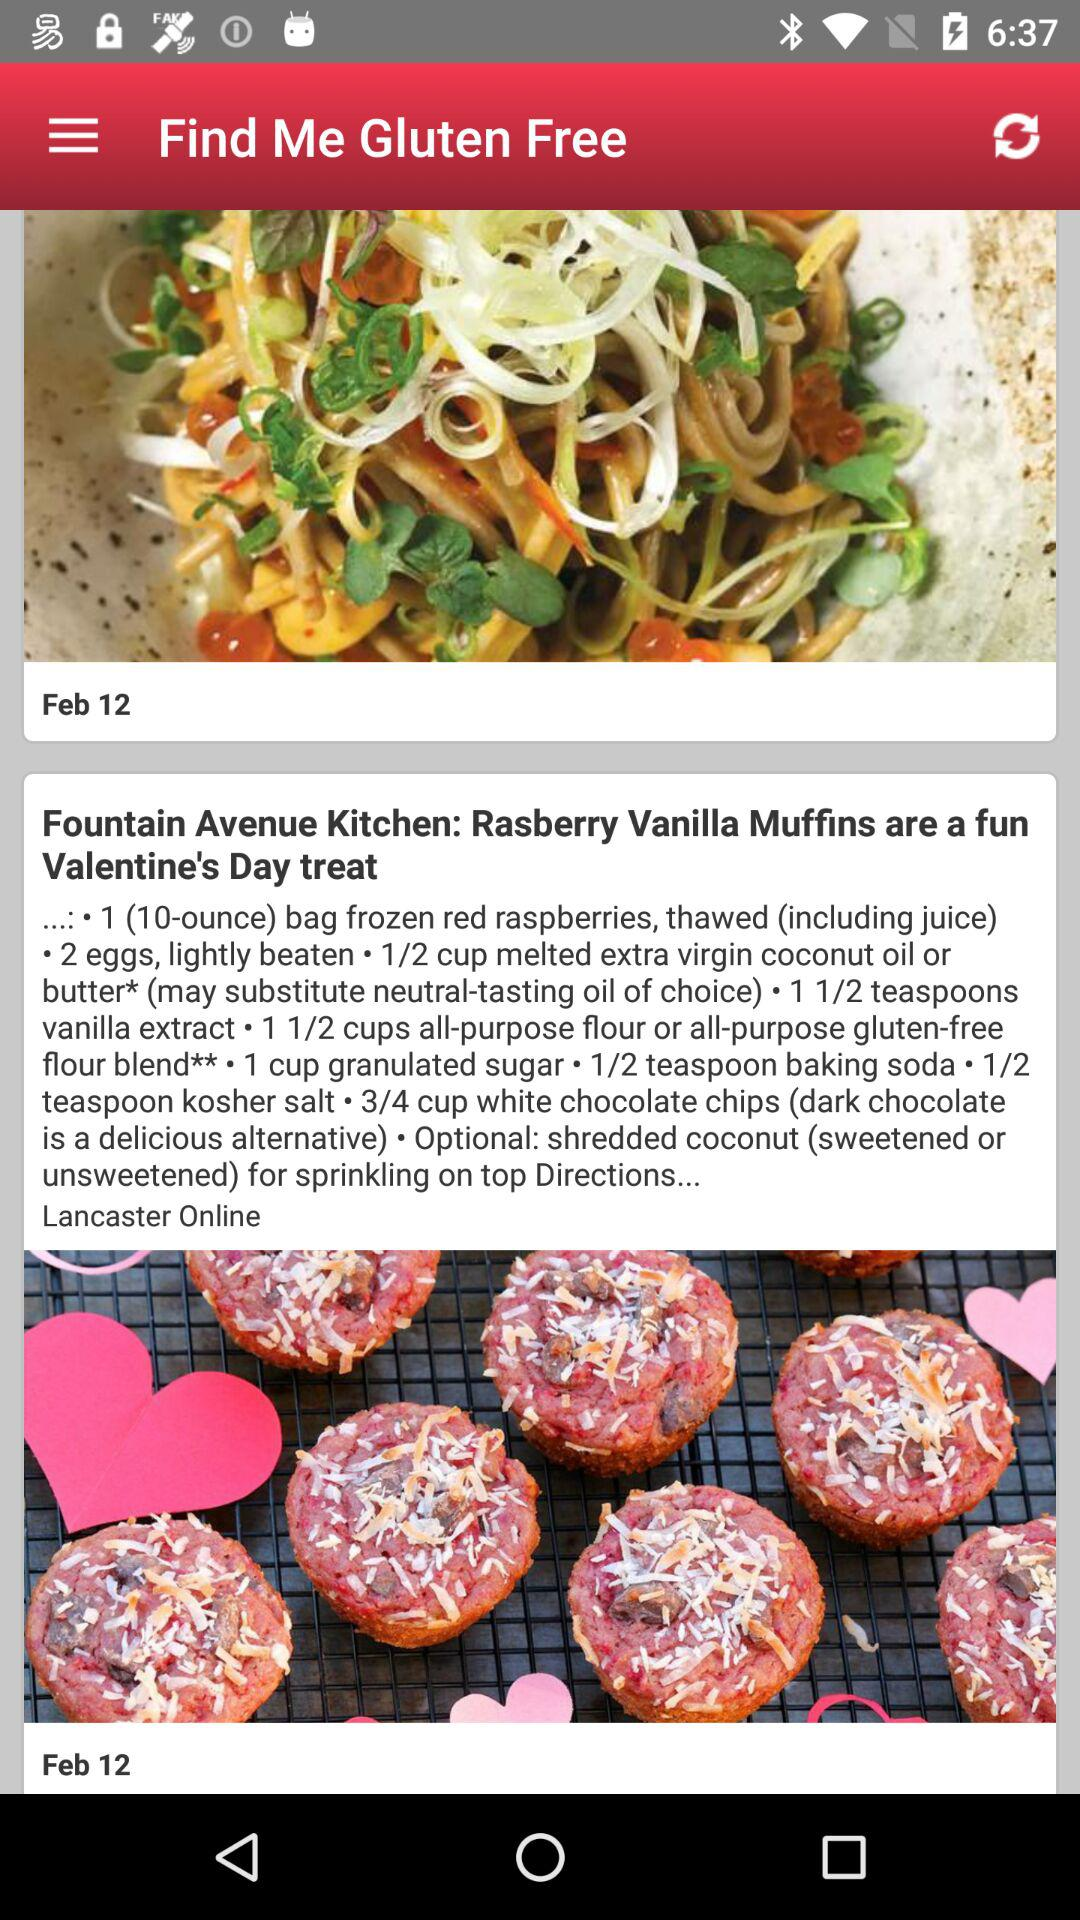How many teaspoons of kosher salt are needed for the dish? The dish needs half a teaspoon of kosher salt. 